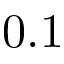Convert formula to latex. <formula><loc_0><loc_0><loc_500><loc_500>0 . 1</formula> 